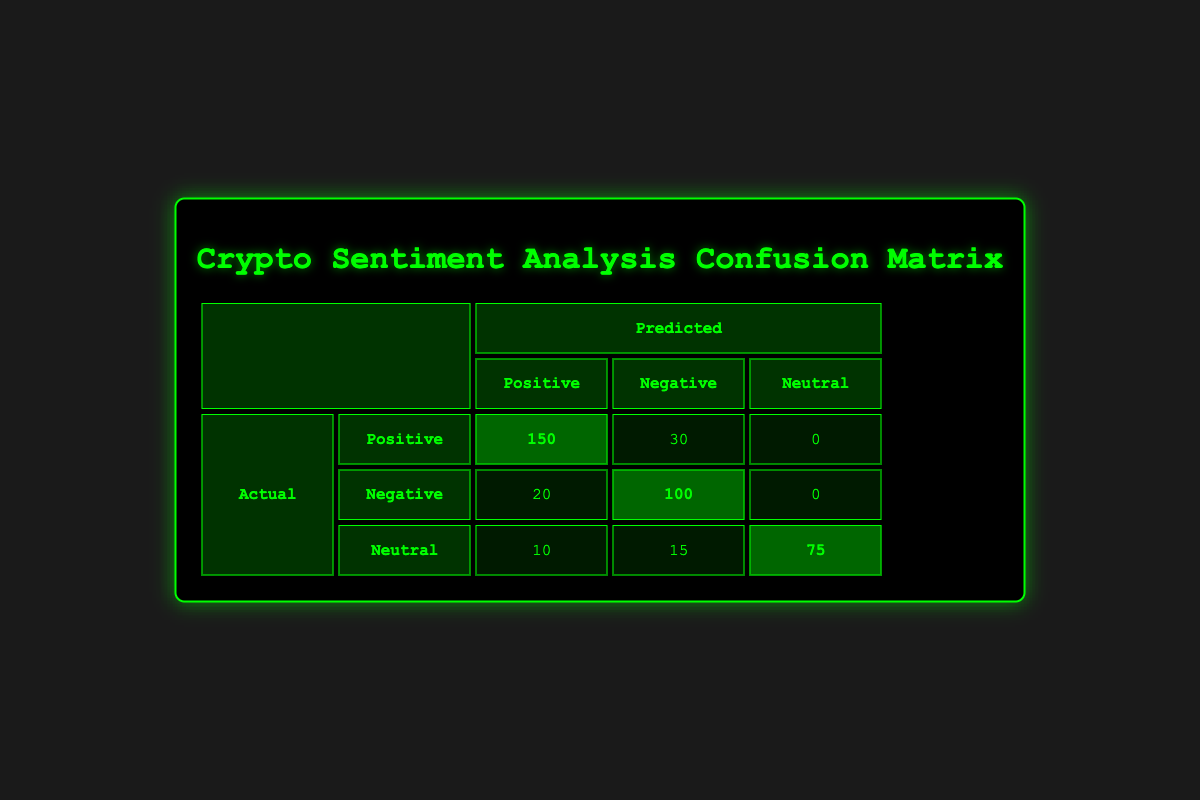What is the number of instances where the sentiment was predicted as positive when it was actually negative? The table shows that there were 20 instances where the actual sentiment was negative, but the prediction was positive. This is directly stated in the row that corresponds to actual negative and predicted positive, with a count of 20.
Answer: 20 How many total predictions were made for neutral sentiments? To find the total predictions for neutral sentiments, we need to look at the entire row for neutral actual sentiments, which are 10 (predicted positive), 15 (predicted negative), and 75 (predicted neutral). Adding these counts together gives us 10 + 15 + 75 = 100.
Answer: 100 What is the count of true positive predictions? True positive predictions occur when the actual sentiment is positive and the predicted sentiment is also positive. Referring to the table, there are 150 such instances in the row for actual positive and predicted positive.
Answer: 150 Did the model ever predict a negative sentiment when the actual sentiment was positive? According to the table, there are instances (30) in which the actual sentiment was positive but predicted negative. Therefore, the statement is true, the model has predicted negative for actual positive sentiments.
Answer: Yes What is the overall accuracy of the sentiment analysis model? To calculate the overall accuracy, we can use the formula: (True Positives + True Negatives) / Total Predictions. From the table, True Positives (150) and True Negatives (100) can be added together to get 250. The total predictions can be calculated by summing all counts: 150 + 30 + 20 + 100 + 10 + 15 + 75 = 400. Therefore, the accuracy is 250 / 400 = 0.625 or 62.5%.
Answer: 62.5% How many predictions were incorrect for positive sentiments? Incorrect predictions for positive sentiments occur when the actual sentiment is positive, but the prediction is negative or neutral. From the table, there are 30 instances where the actual sentiment is positive and predicted negative. The count for those predicted neutral is 0. Thus, the total incorrect predictions for positive sentiments equals 30.
Answer: 30 What is the ratio of true negative predictions to false negative predictions? Looking at the table, true negative predictions (where the actual sentiment is negative and predicted negative) are 100, and false negative predictions (where the actual sentiment is negative but predicted positive) are 20. To find the ratio, we divide 100 by 20, yielding a ratio of 5:1.
Answer: 5:1 What is the highest count of predicted sentiments when actual sentiment is neutral? In the row for actual neutral sentiments, the counts for predictions are 10 (predicted positive), 15 (predicted negative), and 75 (predicted neutral). The highest count among these is 75.
Answer: 75 What percentage of the predictions were neutral sentiments? To find the percentage of neutral sentiments predicted, we first count the neutral predictions: 75 for actual neutral, and then sum this with the neutral predictions for other actual sentiments, which are 0 for positives and negatives. The total neutral predictions are thus just 75. The total predictions are 400. The percentage can be calculated as (75 / 400) * 100 = 18.75%.
Answer: 18.75% 